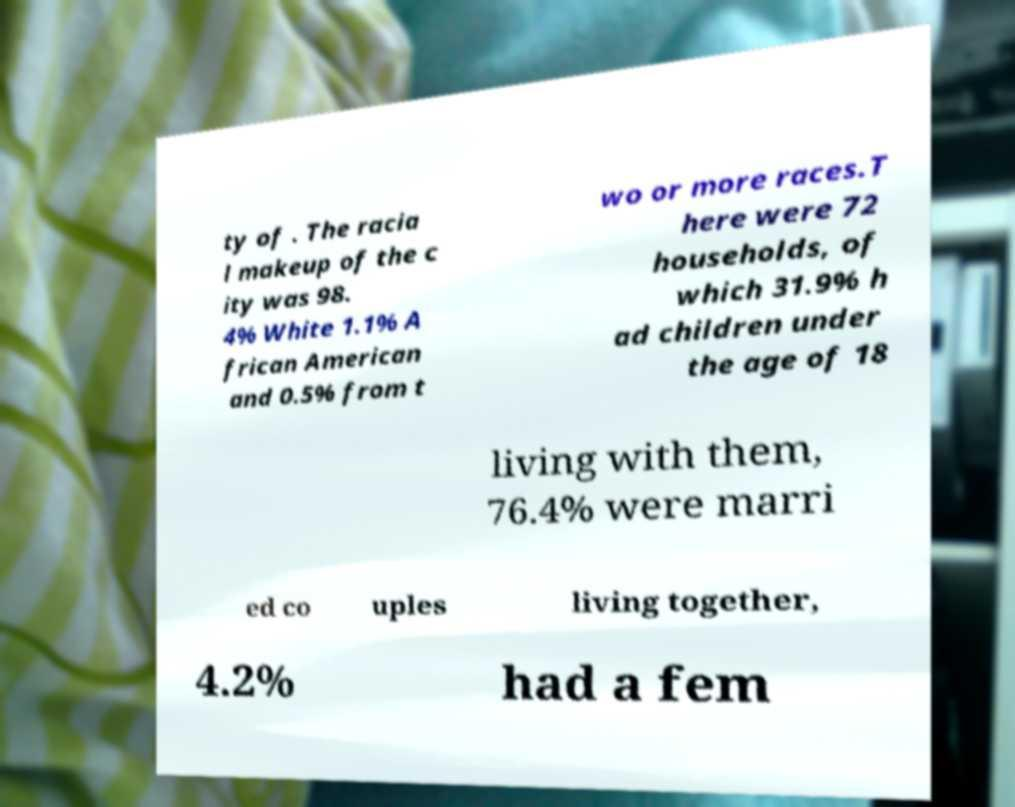Please read and relay the text visible in this image. What does it say? ty of . The racia l makeup of the c ity was 98. 4% White 1.1% A frican American and 0.5% from t wo or more races.T here were 72 households, of which 31.9% h ad children under the age of 18 living with them, 76.4% were marri ed co uples living together, 4.2% had a fem 